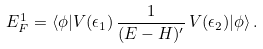Convert formula to latex. <formula><loc_0><loc_0><loc_500><loc_500>E _ { F } ^ { 1 } = \langle \phi | V ( \epsilon _ { 1 } ) \, \frac { 1 } { ( E - H ) ^ { \prime } } \, V ( \epsilon _ { 2 } ) | \phi \rangle \, .</formula> 